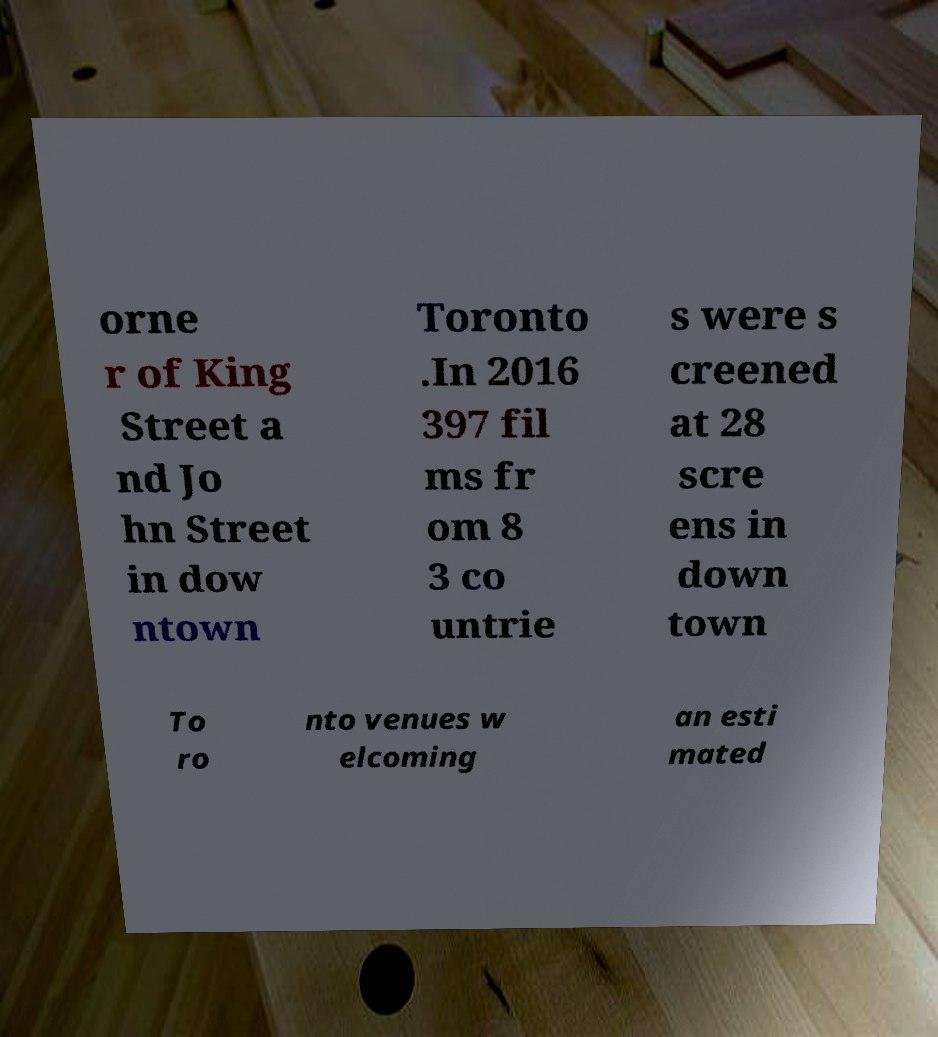Can you accurately transcribe the text from the provided image for me? orne r of King Street a nd Jo hn Street in dow ntown Toronto .In 2016 397 fil ms fr om 8 3 co untrie s were s creened at 28 scre ens in down town To ro nto venues w elcoming an esti mated 